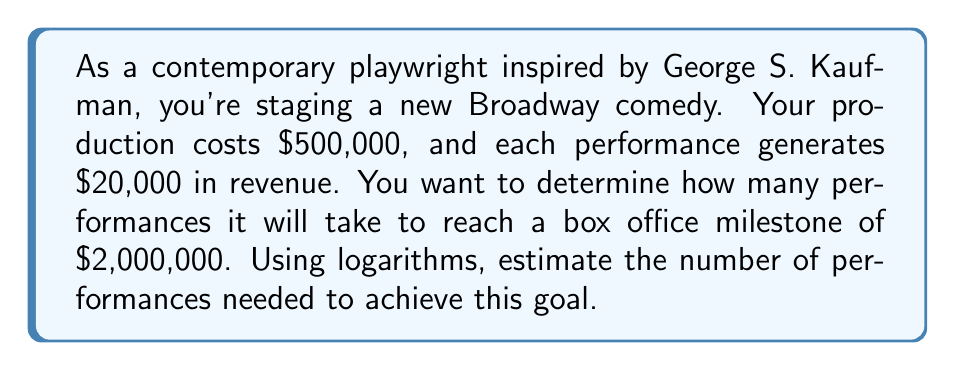Can you solve this math problem? Let's approach this step-by-step using logarithms:

1) First, let's define our variables:
   $x$ = number of performances
   $20,000x$ = total revenue after $x$ performances

2) We want to find when the total revenue minus the production cost equals $2,000,000:
   $20,000x - 500,000 = 2,000,000$

3) Simplify the equation:
   $20,000x = 2,500,000$

4) Divide both sides by 20,000:
   $x = 125$

5) However, we want to solve this using logarithms. Let's go back to step 3 and apply log to both sides:
   $\log(20,000x) = \log(2,500,000)$

6) Using the logarithm property $\log(ab) = \log(a) + \log(b)$:
   $\log(20,000) + \log(x) = \log(2,500,000)$

7) Subtract $\log(20,000)$ from both sides:
   $\log(x) = \log(2,500,000) - \log(20,000)$

8) Now, we can use the change of base formula to convert to base 10 logarithms:
   $x = 10^{\log(2,500,000) - \log(20,000)}$

9) Calculate:
   $x = 10^{6.39794 - 4.30103} = 10^{2.09691} \approx 125$

This logarithmic approach gives us the same result as the algebraic method, confirming our calculation.
Answer: Approximately 125 performances are needed to reach the $2,000,000 box office milestone. 